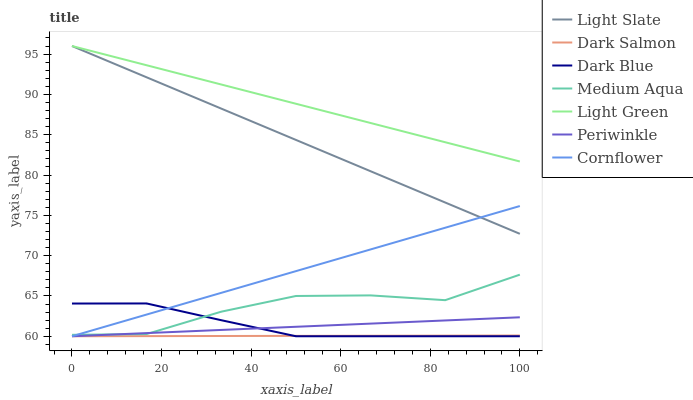Does Dark Salmon have the minimum area under the curve?
Answer yes or no. Yes. Does Light Green have the maximum area under the curve?
Answer yes or no. Yes. Does Light Slate have the minimum area under the curve?
Answer yes or no. No. Does Light Slate have the maximum area under the curve?
Answer yes or no. No. Is Dark Salmon the smoothest?
Answer yes or no. Yes. Is Medium Aqua the roughest?
Answer yes or no. Yes. Is Light Slate the smoothest?
Answer yes or no. No. Is Light Slate the roughest?
Answer yes or no. No. Does Cornflower have the lowest value?
Answer yes or no. Yes. Does Light Slate have the lowest value?
Answer yes or no. No. Does Light Green have the highest value?
Answer yes or no. Yes. Does Dark Salmon have the highest value?
Answer yes or no. No. Is Medium Aqua less than Light Slate?
Answer yes or no. Yes. Is Light Green greater than Medium Aqua?
Answer yes or no. Yes. Does Periwinkle intersect Dark Blue?
Answer yes or no. Yes. Is Periwinkle less than Dark Blue?
Answer yes or no. No. Is Periwinkle greater than Dark Blue?
Answer yes or no. No. Does Medium Aqua intersect Light Slate?
Answer yes or no. No. 